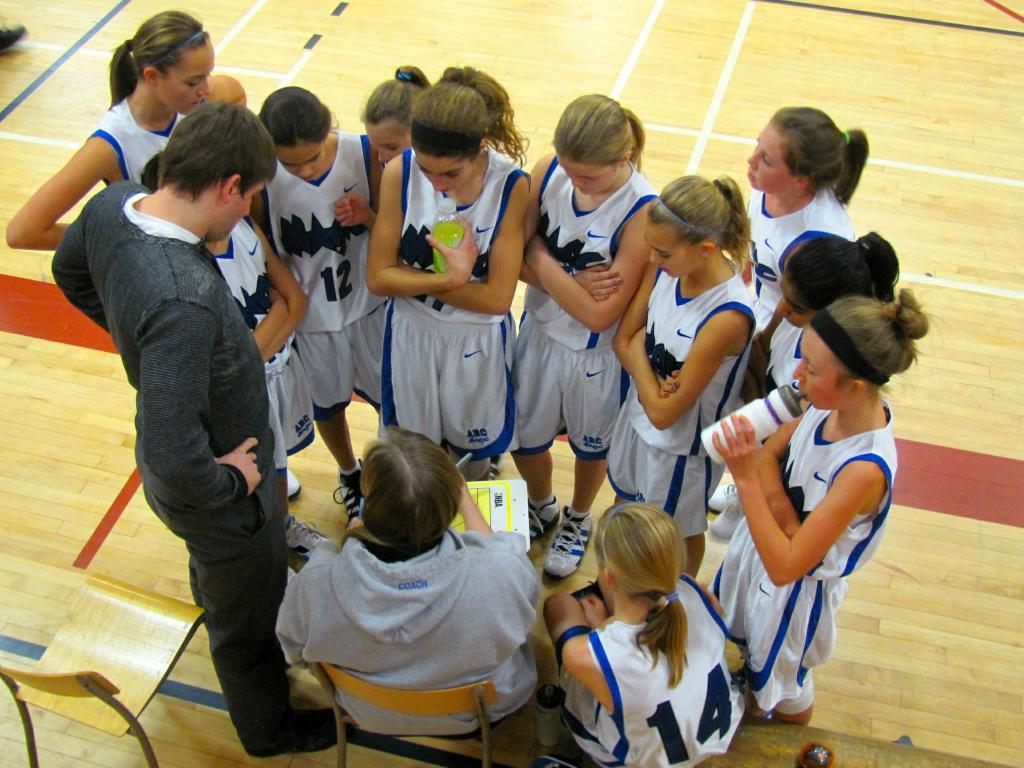<image>
Summarize the visual content of the image. A group of young female basketball players are huddled together on the court and their uniforms say Magic. 